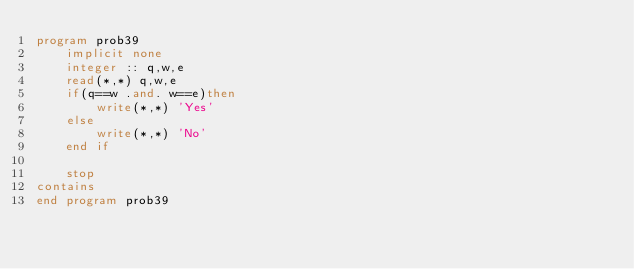<code> <loc_0><loc_0><loc_500><loc_500><_FORTRAN_>program prob39
    implicit none
    integer :: q,w,e
    read(*,*) q,w,e
    if(q==w .and. w==e)then
        write(*,*) 'Yes'
    else
        write(*,*) 'No'
    end if

    stop
contains
end program prob39</code> 